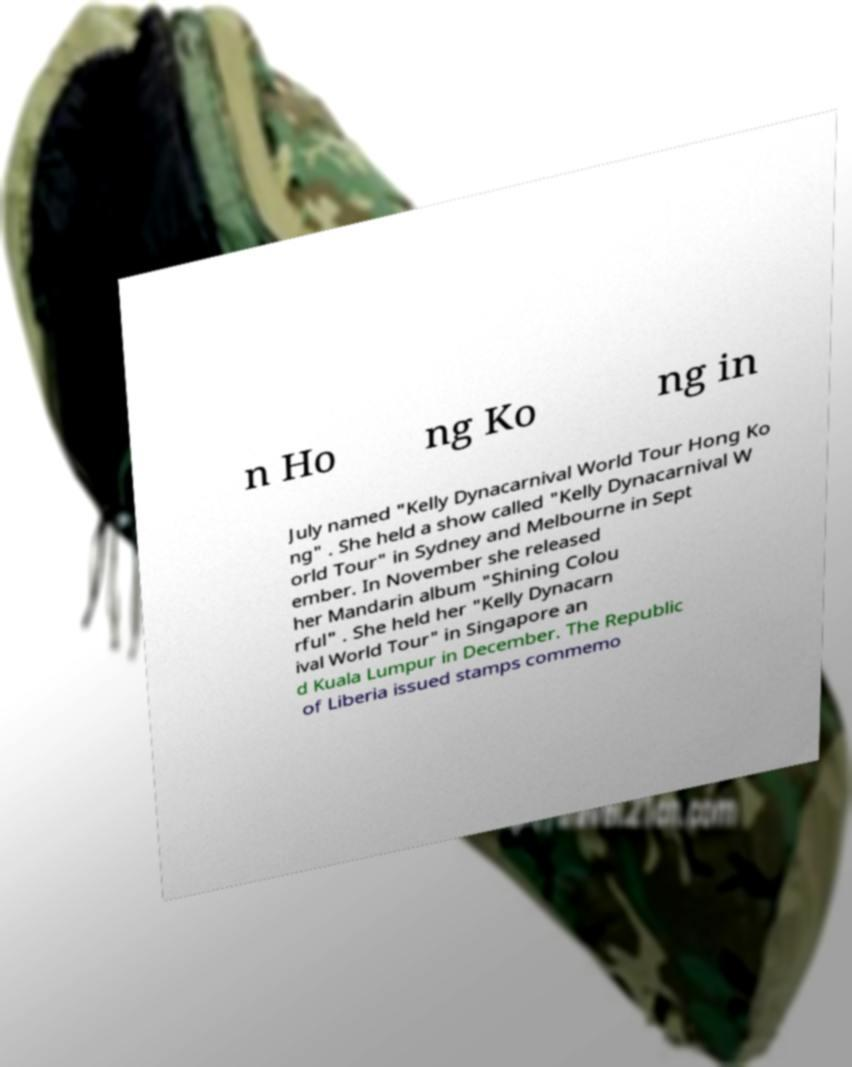I need the written content from this picture converted into text. Can you do that? n Ho ng Ko ng in July named "Kelly Dynacarnival World Tour Hong Ko ng" . She held a show called "Kelly Dynacarnival W orld Tour" in Sydney and Melbourne in Sept ember. In November she released her Mandarin album "Shining Colou rful" . She held her "Kelly Dynacarn ival World Tour" in Singapore an d Kuala Lumpur in December. The Republic of Liberia issued stamps commemo 